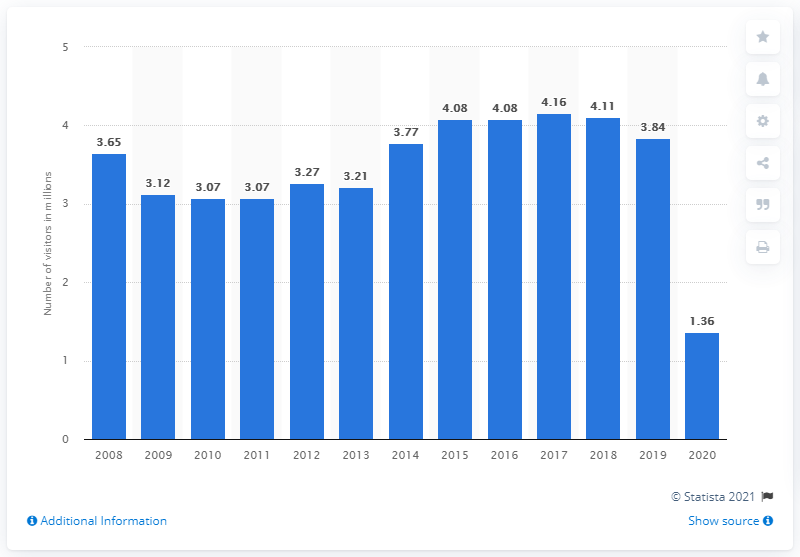Mention a couple of crucial points in this snapshot. In 2020, there were 1.36 million visitors to the Korean War Veterans Memorial. 